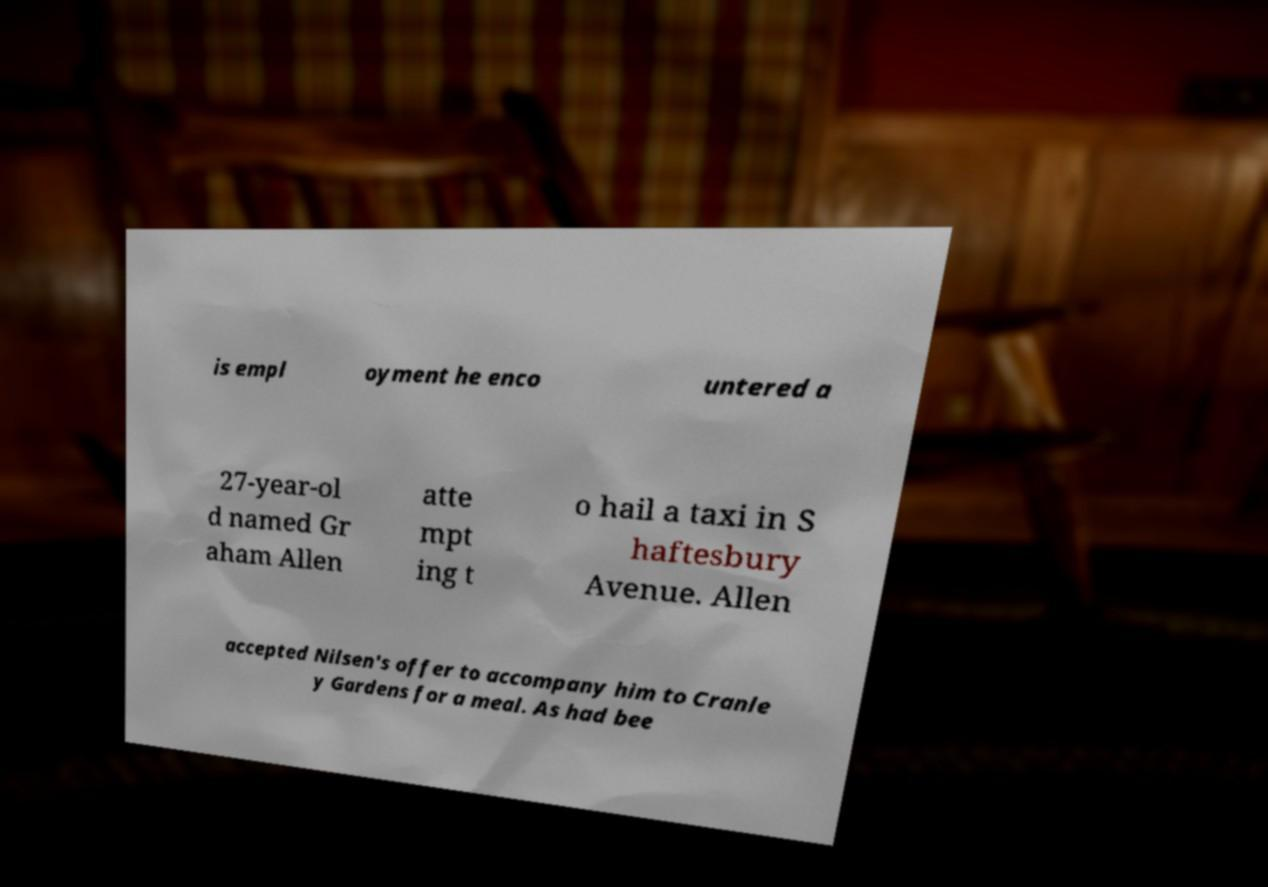Can you read and provide the text displayed in the image?This photo seems to have some interesting text. Can you extract and type it out for me? is empl oyment he enco untered a 27-year-ol d named Gr aham Allen atte mpt ing t o hail a taxi in S haftesbury Avenue. Allen accepted Nilsen's offer to accompany him to Cranle y Gardens for a meal. As had bee 